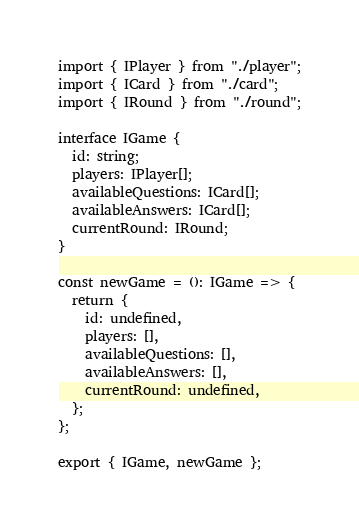Convert code to text. <code><loc_0><loc_0><loc_500><loc_500><_TypeScript_>import { IPlayer } from "./player";
import { ICard } from "./card";
import { IRound } from "./round";

interface IGame {
  id: string;
  players: IPlayer[];
  availableQuestions: ICard[];
  availableAnswers: ICard[];
  currentRound: IRound;
}

const newGame = (): IGame => {
  return {
    id: undefined,
    players: [],
    availableQuestions: [],
    availableAnswers: [],
    currentRound: undefined,
  };
};

export { IGame, newGame };
</code> 